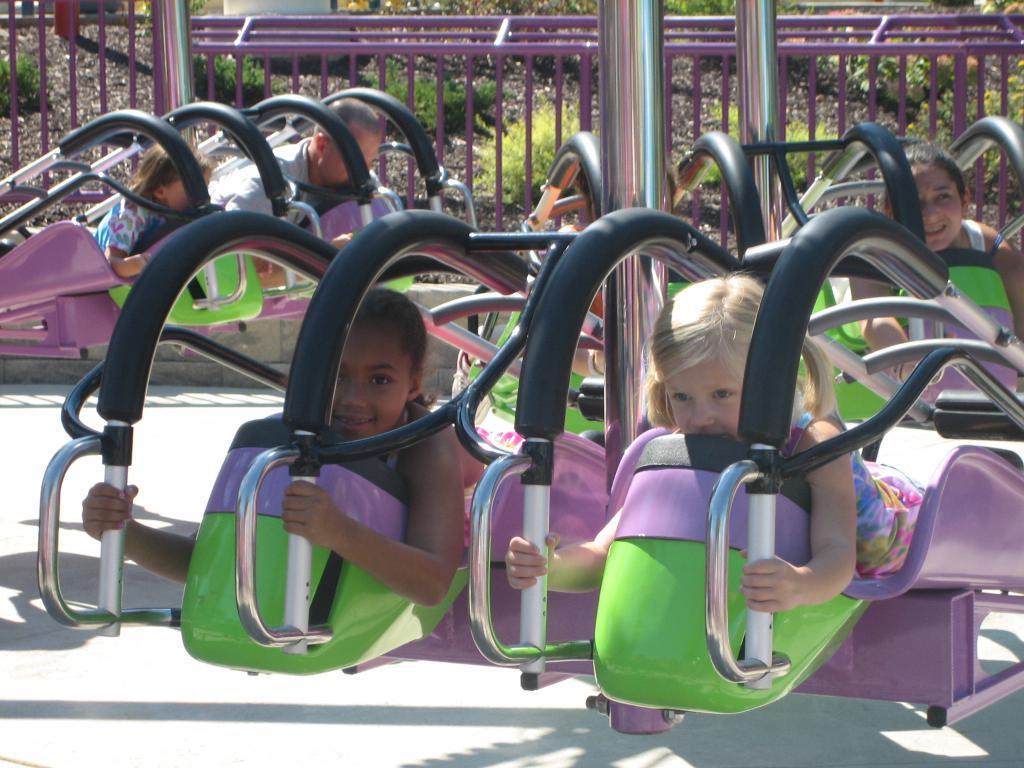Please provide a concise description of this image. In the picture we can see a amusement park ride with some people in it and in the background, we can see a railing and some plants on the path. 